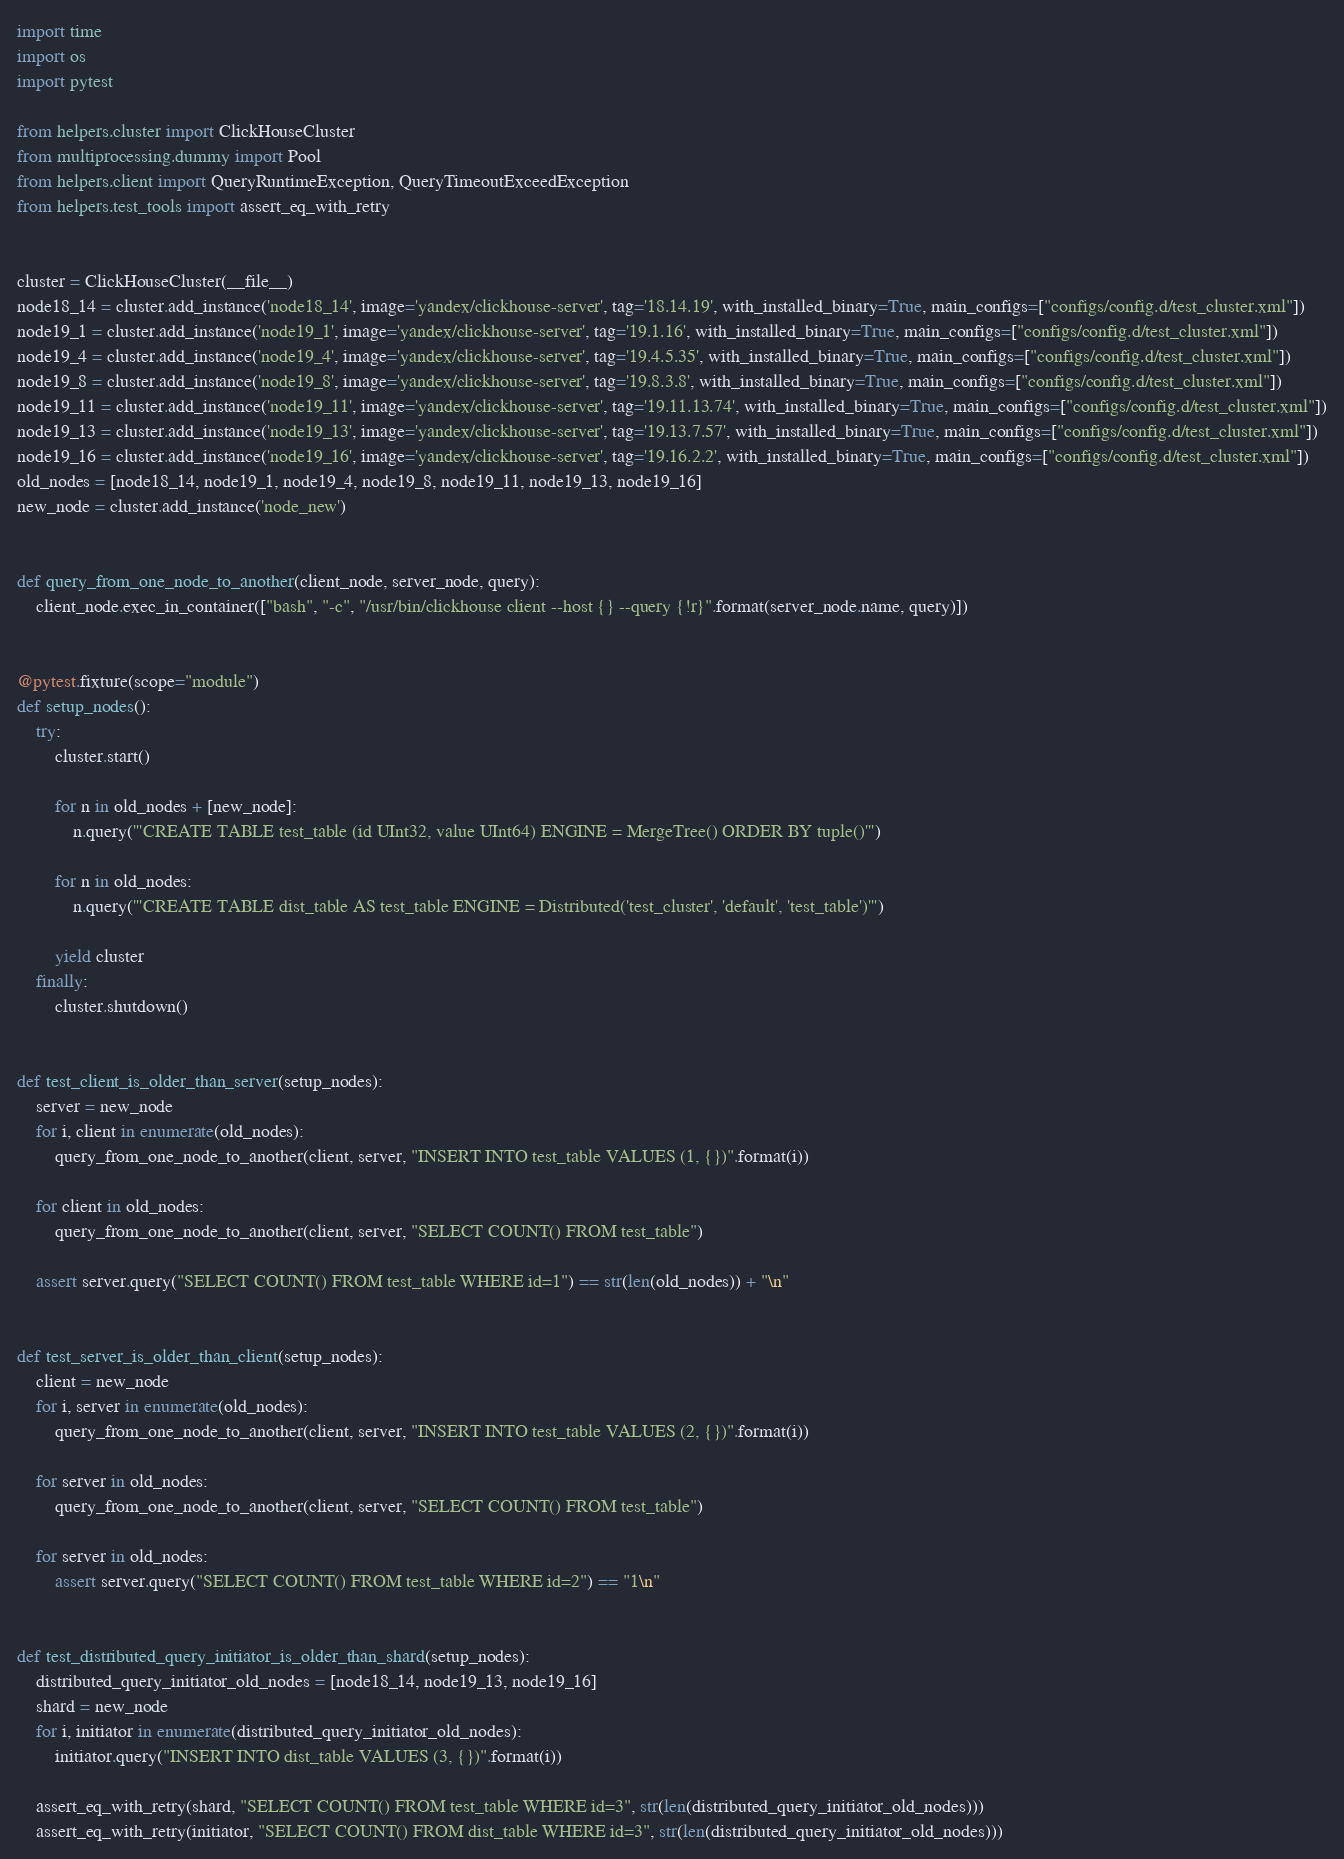Convert code to text. <code><loc_0><loc_0><loc_500><loc_500><_Python_>
import time
import os
import pytest

from helpers.cluster import ClickHouseCluster
from multiprocessing.dummy import Pool
from helpers.client import QueryRuntimeException, QueryTimeoutExceedException
from helpers.test_tools import assert_eq_with_retry


cluster = ClickHouseCluster(__file__)
node18_14 = cluster.add_instance('node18_14', image='yandex/clickhouse-server', tag='18.14.19', with_installed_binary=True, main_configs=["configs/config.d/test_cluster.xml"])
node19_1 = cluster.add_instance('node19_1', image='yandex/clickhouse-server', tag='19.1.16', with_installed_binary=True, main_configs=["configs/config.d/test_cluster.xml"])
node19_4 = cluster.add_instance('node19_4', image='yandex/clickhouse-server', tag='19.4.5.35', with_installed_binary=True, main_configs=["configs/config.d/test_cluster.xml"])
node19_8 = cluster.add_instance('node19_8', image='yandex/clickhouse-server', tag='19.8.3.8', with_installed_binary=True, main_configs=["configs/config.d/test_cluster.xml"])
node19_11 = cluster.add_instance('node19_11', image='yandex/clickhouse-server', tag='19.11.13.74', with_installed_binary=True, main_configs=["configs/config.d/test_cluster.xml"])
node19_13 = cluster.add_instance('node19_13', image='yandex/clickhouse-server', tag='19.13.7.57', with_installed_binary=True, main_configs=["configs/config.d/test_cluster.xml"])
node19_16 = cluster.add_instance('node19_16', image='yandex/clickhouse-server', tag='19.16.2.2', with_installed_binary=True, main_configs=["configs/config.d/test_cluster.xml"])
old_nodes = [node18_14, node19_1, node19_4, node19_8, node19_11, node19_13, node19_16]
new_node = cluster.add_instance('node_new')


def query_from_one_node_to_another(client_node, server_node, query):
    client_node.exec_in_container(["bash", "-c", "/usr/bin/clickhouse client --host {} --query {!r}".format(server_node.name, query)])


@pytest.fixture(scope="module")
def setup_nodes():
    try:
        cluster.start()

        for n in old_nodes + [new_node]:
            n.query('''CREATE TABLE test_table (id UInt32, value UInt64) ENGINE = MergeTree() ORDER BY tuple()''')

        for n in old_nodes:
            n.query('''CREATE TABLE dist_table AS test_table ENGINE = Distributed('test_cluster', 'default', 'test_table')''')

        yield cluster
    finally:
        cluster.shutdown()


def test_client_is_older_than_server(setup_nodes):
    server = new_node
    for i, client in enumerate(old_nodes):
        query_from_one_node_to_another(client, server, "INSERT INTO test_table VALUES (1, {})".format(i))

    for client in old_nodes:
        query_from_one_node_to_another(client, server, "SELECT COUNT() FROM test_table")

    assert server.query("SELECT COUNT() FROM test_table WHERE id=1") == str(len(old_nodes)) + "\n"


def test_server_is_older_than_client(setup_nodes):
    client = new_node
    for i, server in enumerate(old_nodes):
        query_from_one_node_to_another(client, server, "INSERT INTO test_table VALUES (2, {})".format(i))

    for server in old_nodes:
        query_from_one_node_to_another(client, server, "SELECT COUNT() FROM test_table")

    for server in old_nodes:
        assert server.query("SELECT COUNT() FROM test_table WHERE id=2") == "1\n"


def test_distributed_query_initiator_is_older_than_shard(setup_nodes):
    distributed_query_initiator_old_nodes = [node18_14, node19_13, node19_16]
    shard = new_node
    for i, initiator in enumerate(distributed_query_initiator_old_nodes):
        initiator.query("INSERT INTO dist_table VALUES (3, {})".format(i))

    assert_eq_with_retry(shard, "SELECT COUNT() FROM test_table WHERE id=3", str(len(distributed_query_initiator_old_nodes)))
    assert_eq_with_retry(initiator, "SELECT COUNT() FROM dist_table WHERE id=3", str(len(distributed_query_initiator_old_nodes)))
</code> 